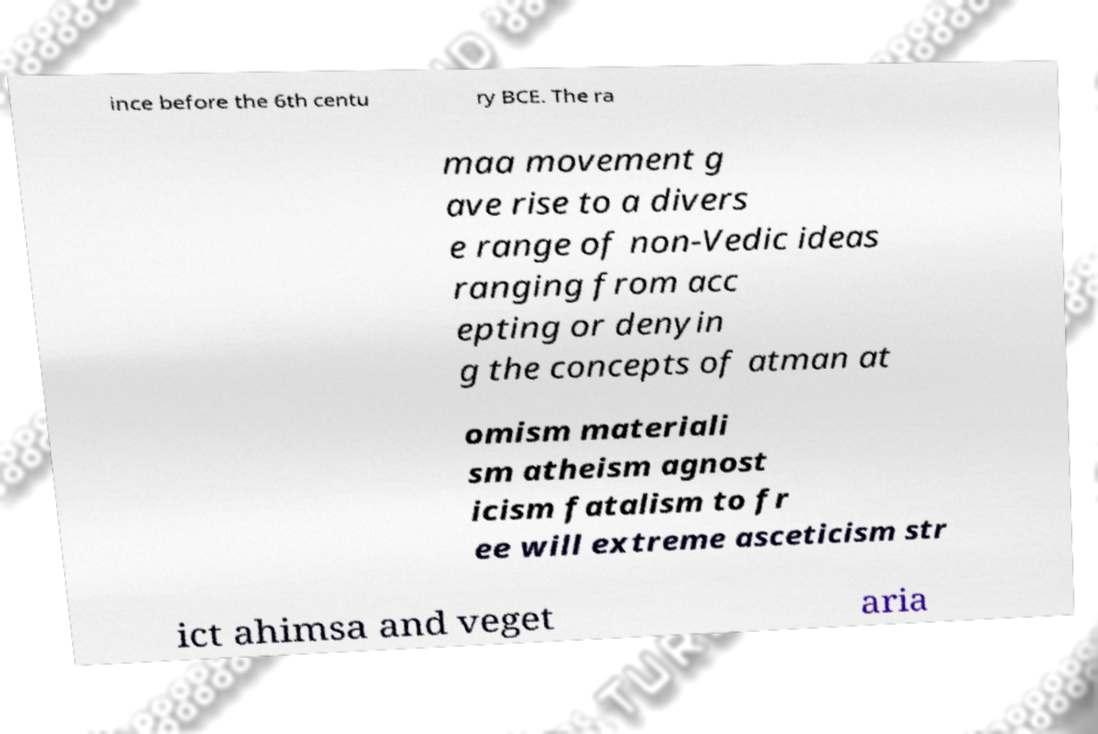For documentation purposes, I need the text within this image transcribed. Could you provide that? ince before the 6th centu ry BCE. The ra maa movement g ave rise to a divers e range of non-Vedic ideas ranging from acc epting or denyin g the concepts of atman at omism materiali sm atheism agnost icism fatalism to fr ee will extreme asceticism str ict ahimsa and veget aria 